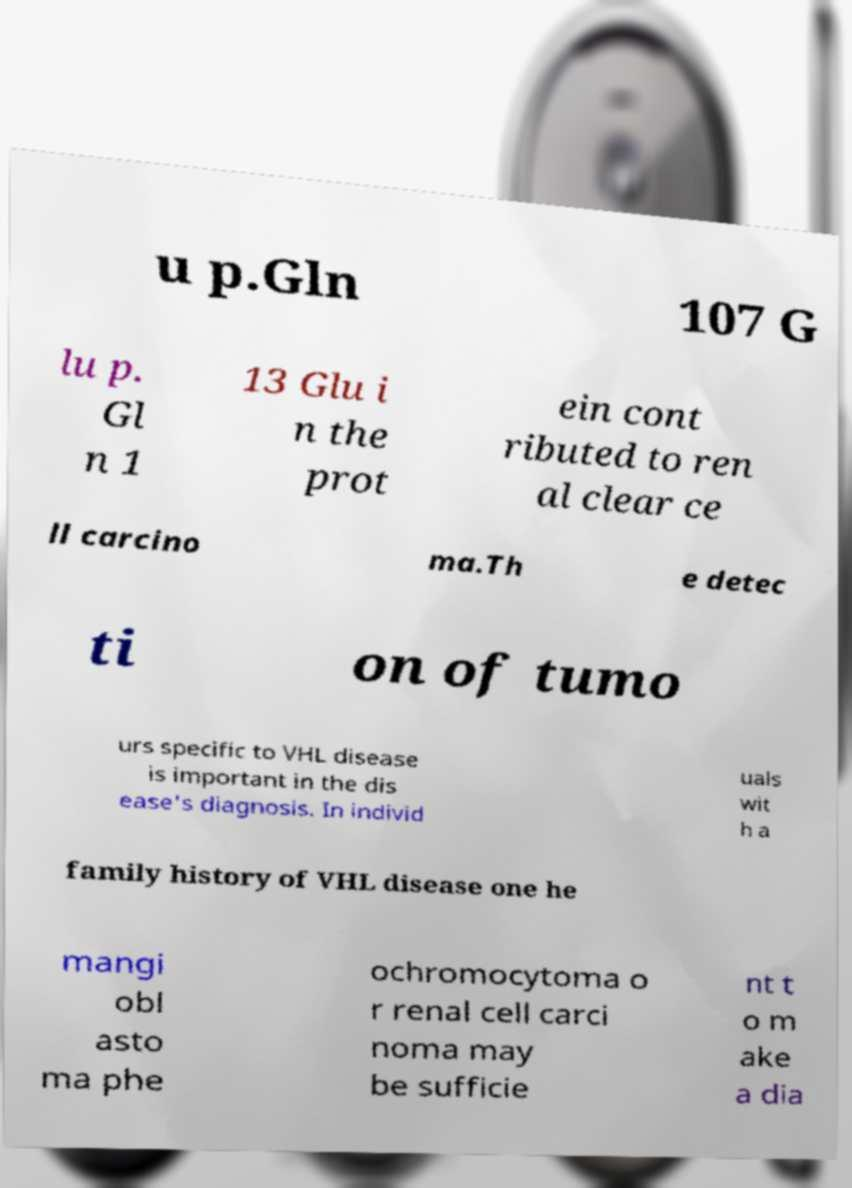Could you extract and type out the text from this image? u p.Gln 107 G lu p. Gl n 1 13 Glu i n the prot ein cont ributed to ren al clear ce ll carcino ma.Th e detec ti on of tumo urs specific to VHL disease is important in the dis ease's diagnosis. In individ uals wit h a family history of VHL disease one he mangi obl asto ma phe ochromocytoma o r renal cell carci noma may be sufficie nt t o m ake a dia 